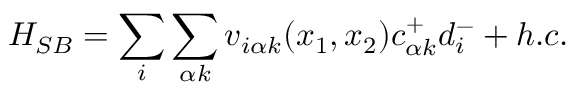Convert formula to latex. <formula><loc_0><loc_0><loc_500><loc_500>H _ { S B } = \sum _ { i } \sum _ { \alpha k } v _ { i \alpha k } ( x _ { 1 } , x _ { 2 } ) c _ { \alpha k } ^ { + } d _ { i } ^ { - } + h . c .</formula> 